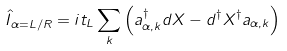<formula> <loc_0><loc_0><loc_500><loc_500>\hat { I } _ { \alpha = L / R } = i t _ { L } \sum _ { k } \left ( a ^ { \dagger } _ { \alpha , k } d X - d ^ { \dagger } X ^ { \dagger } a _ { { \alpha } , k } \right )</formula> 